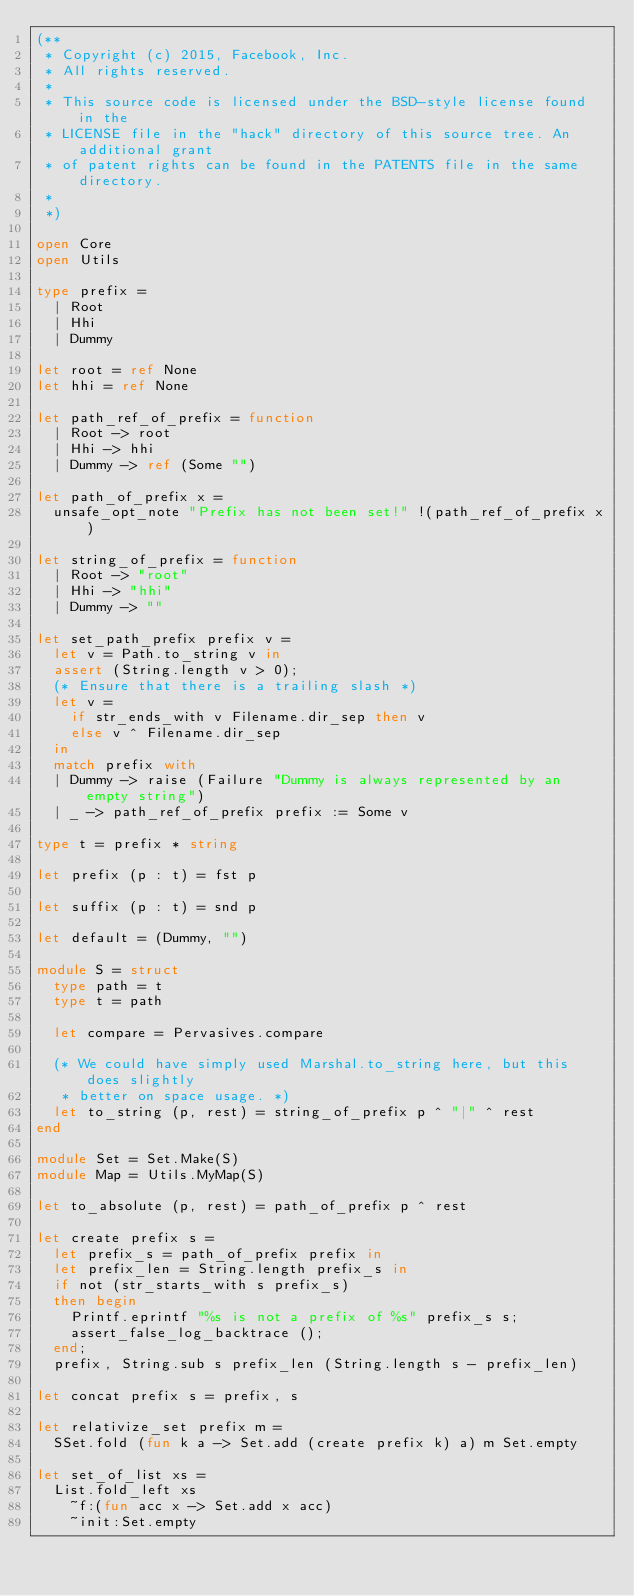<code> <loc_0><loc_0><loc_500><loc_500><_OCaml_>(**
 * Copyright (c) 2015, Facebook, Inc.
 * All rights reserved.
 *
 * This source code is licensed under the BSD-style license found in the
 * LICENSE file in the "hack" directory of this source tree. An additional grant
 * of patent rights can be found in the PATENTS file in the same directory.
 *
 *)

open Core
open Utils

type prefix =
  | Root
  | Hhi
  | Dummy

let root = ref None
let hhi = ref None

let path_ref_of_prefix = function
  | Root -> root
  | Hhi -> hhi
  | Dummy -> ref (Some "")

let path_of_prefix x =
  unsafe_opt_note "Prefix has not been set!" !(path_ref_of_prefix x)

let string_of_prefix = function
  | Root -> "root"
  | Hhi -> "hhi"
  | Dummy -> ""

let set_path_prefix prefix v =
  let v = Path.to_string v in
  assert (String.length v > 0);
  (* Ensure that there is a trailing slash *)
  let v =
    if str_ends_with v Filename.dir_sep then v
    else v ^ Filename.dir_sep
  in
  match prefix with
  | Dummy -> raise (Failure "Dummy is always represented by an empty string")
  | _ -> path_ref_of_prefix prefix := Some v

type t = prefix * string

let prefix (p : t) = fst p

let suffix (p : t) = snd p

let default = (Dummy, "")

module S = struct
  type path = t
  type t = path

  let compare = Pervasives.compare

  (* We could have simply used Marshal.to_string here, but this does slightly
   * better on space usage. *)
  let to_string (p, rest) = string_of_prefix p ^ "|" ^ rest
end

module Set = Set.Make(S)
module Map = Utils.MyMap(S)

let to_absolute (p, rest) = path_of_prefix p ^ rest

let create prefix s =
  let prefix_s = path_of_prefix prefix in
  let prefix_len = String.length prefix_s in
  if not (str_starts_with s prefix_s)
  then begin
    Printf.eprintf "%s is not a prefix of %s" prefix_s s;
    assert_false_log_backtrace ();
  end;
  prefix, String.sub s prefix_len (String.length s - prefix_len)

let concat prefix s = prefix, s

let relativize_set prefix m =
  SSet.fold (fun k a -> Set.add (create prefix k) a) m Set.empty

let set_of_list xs =
  List.fold_left xs
    ~f:(fun acc x -> Set.add x acc)
    ~init:Set.empty
</code> 